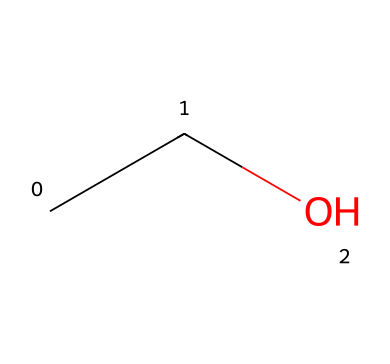how many carbon atoms are in this chemical? The given SMILES representation (CCO) indicates two 'C' atoms in the structure, hence there are two carbon atoms.
Answer: 2 how many hydrogen atoms are present in this chemical? By analyzing the structure from the SMILES notation, with two carbon atoms (C), positionally each carbon can bond with additional hydrogen atoms. Hence, the total number of hydrogen atoms is five (C2H5O).
Answer: 6 what is the primary functional group in this compound? The structure shows a hydroxyl group (-OH) attached to a carbon chain, indicating that this compound is an alcohol, making the hydroxyl group the primary functional group.
Answer: hydroxyl is ethanol an electrolyte? Ethanol does not dissociate into ions in solution, categorizing it as a non-electrolyte.
Answer: no what type of bonding is primarily present in ethanol? In ethanol (C2H5OH), the bonding mainly consists of covalent bonds, as seen in the connections between carbon, hydrogen, and oxygen atoms.
Answer: covalent how does ethanol interact with water? Ethanol is highly soluble in water due to hydrogen bonding between the hydroxyl group of ethanol and the water molecules, facilitating interactions.
Answer: it is soluble what is the molecular formula of ethanol? The structural representation indicates that ethanol has two carbon atoms, six hydrogen atoms, and one oxygen atom, leading to the molecular formula C2H6O.
Answer: C2H6O 